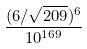<formula> <loc_0><loc_0><loc_500><loc_500>\frac { ( 6 / \sqrt { 2 0 9 } ) ^ { 6 } } { 1 0 ^ { 1 6 9 } }</formula> 